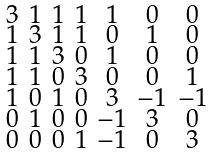Convert formula to latex. <formula><loc_0><loc_0><loc_500><loc_500>\begin{smallmatrix} 3 & 1 & 1 & 1 & 1 & 0 & 0 \\ 1 & 3 & 1 & 1 & 0 & 1 & 0 \\ 1 & 1 & 3 & 0 & 1 & 0 & 0 \\ 1 & 1 & 0 & 3 & 0 & 0 & 1 \\ 1 & 0 & 1 & 0 & 3 & - 1 & - 1 \\ 0 & 1 & 0 & 0 & - 1 & 3 & 0 \\ 0 & 0 & 0 & 1 & - 1 & 0 & 3 \end{smallmatrix}</formula> 